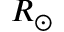Convert formula to latex. <formula><loc_0><loc_0><loc_500><loc_500>R _ { \odot }</formula> 